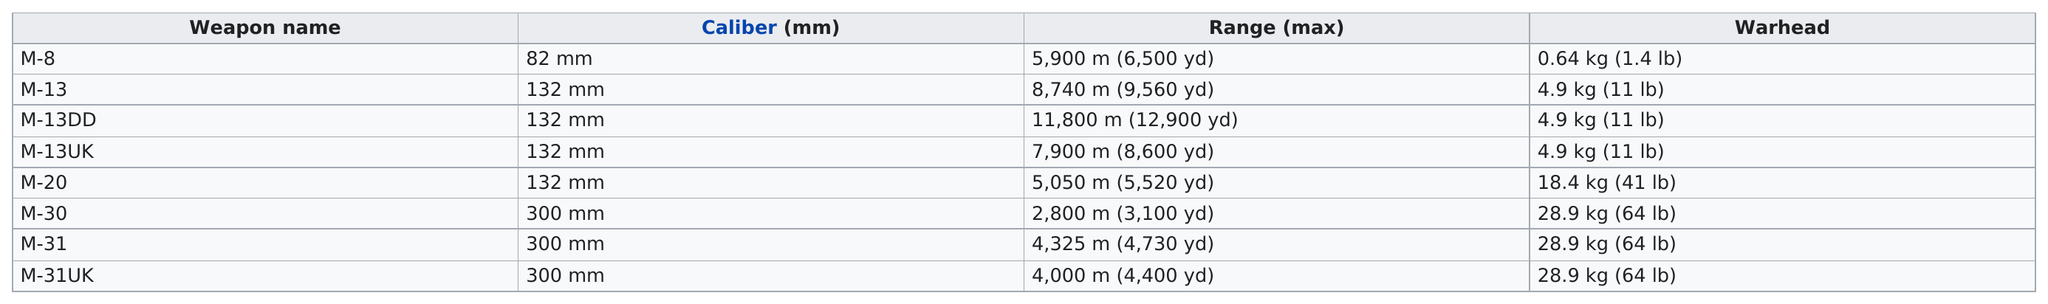Indicate a few pertinent items in this graphic. The M-13DD Katyusha launcher has the best range of all Katyusha launchers. The three weapons, M-30, M-31, and M-31UK, all have the highest caliber among their respective categories. Of the weapons available, how many have a range that is less than 4,000 meters? 